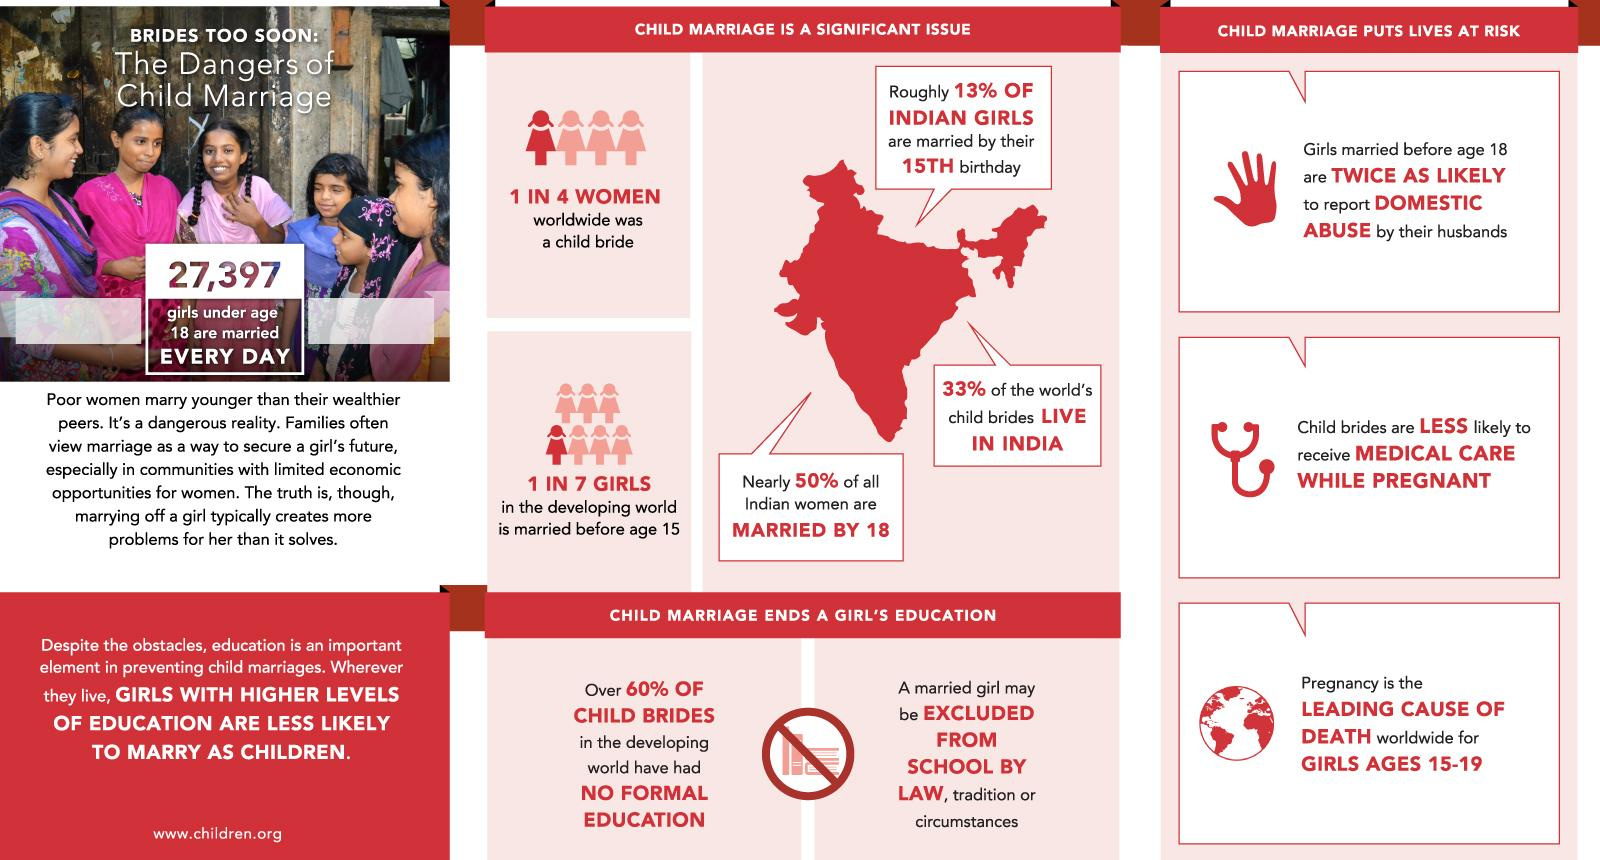Point out several critical features in this image. Approximately 67% of the world's child brides live in other parts of the world. 